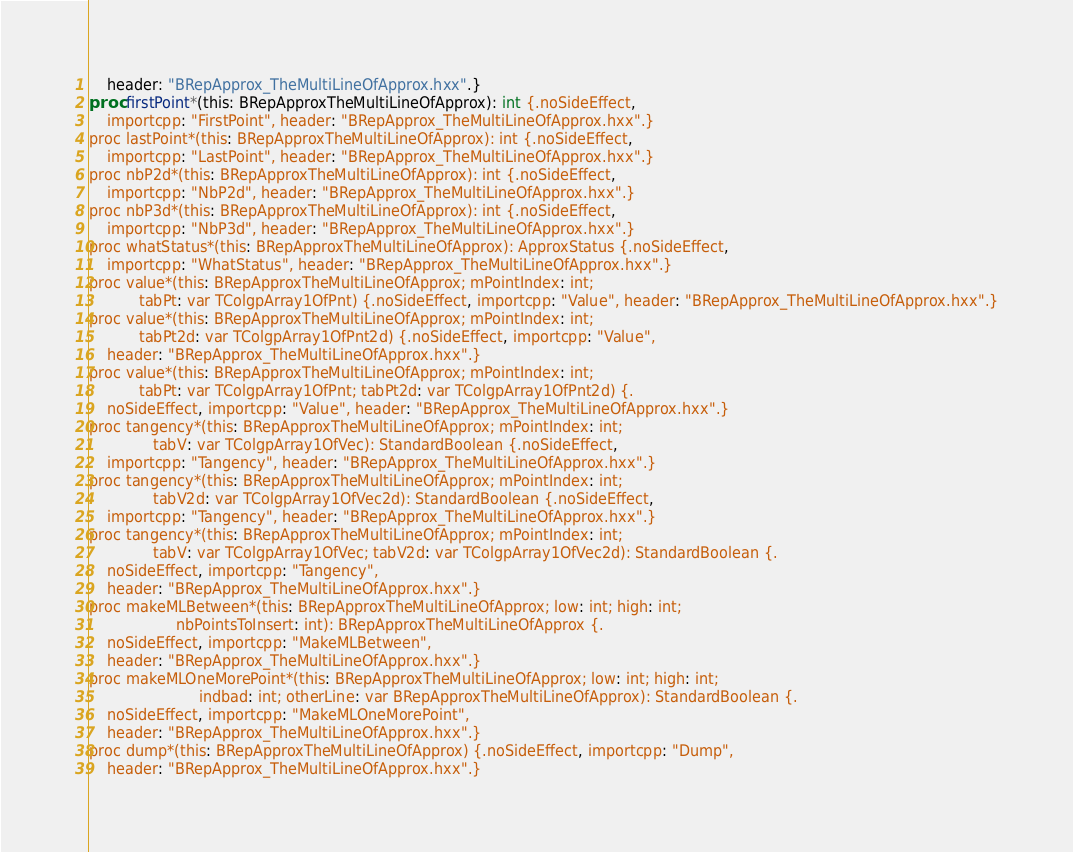<code> <loc_0><loc_0><loc_500><loc_500><_Nim_>    header: "BRepApprox_TheMultiLineOfApprox.hxx".}
proc firstPoint*(this: BRepApproxTheMultiLineOfApprox): int {.noSideEffect,
    importcpp: "FirstPoint", header: "BRepApprox_TheMultiLineOfApprox.hxx".}
proc lastPoint*(this: BRepApproxTheMultiLineOfApprox): int {.noSideEffect,
    importcpp: "LastPoint", header: "BRepApprox_TheMultiLineOfApprox.hxx".}
proc nbP2d*(this: BRepApproxTheMultiLineOfApprox): int {.noSideEffect,
    importcpp: "NbP2d", header: "BRepApprox_TheMultiLineOfApprox.hxx".}
proc nbP3d*(this: BRepApproxTheMultiLineOfApprox): int {.noSideEffect,
    importcpp: "NbP3d", header: "BRepApprox_TheMultiLineOfApprox.hxx".}
proc whatStatus*(this: BRepApproxTheMultiLineOfApprox): ApproxStatus {.noSideEffect,
    importcpp: "WhatStatus", header: "BRepApprox_TheMultiLineOfApprox.hxx".}
proc value*(this: BRepApproxTheMultiLineOfApprox; mPointIndex: int;
           tabPt: var TColgpArray1OfPnt) {.noSideEffect, importcpp: "Value", header: "BRepApprox_TheMultiLineOfApprox.hxx".}
proc value*(this: BRepApproxTheMultiLineOfApprox; mPointIndex: int;
           tabPt2d: var TColgpArray1OfPnt2d) {.noSideEffect, importcpp: "Value",
    header: "BRepApprox_TheMultiLineOfApprox.hxx".}
proc value*(this: BRepApproxTheMultiLineOfApprox; mPointIndex: int;
           tabPt: var TColgpArray1OfPnt; tabPt2d: var TColgpArray1OfPnt2d) {.
    noSideEffect, importcpp: "Value", header: "BRepApprox_TheMultiLineOfApprox.hxx".}
proc tangency*(this: BRepApproxTheMultiLineOfApprox; mPointIndex: int;
              tabV: var TColgpArray1OfVec): StandardBoolean {.noSideEffect,
    importcpp: "Tangency", header: "BRepApprox_TheMultiLineOfApprox.hxx".}
proc tangency*(this: BRepApproxTheMultiLineOfApprox; mPointIndex: int;
              tabV2d: var TColgpArray1OfVec2d): StandardBoolean {.noSideEffect,
    importcpp: "Tangency", header: "BRepApprox_TheMultiLineOfApprox.hxx".}
proc tangency*(this: BRepApproxTheMultiLineOfApprox; mPointIndex: int;
              tabV: var TColgpArray1OfVec; tabV2d: var TColgpArray1OfVec2d): StandardBoolean {.
    noSideEffect, importcpp: "Tangency",
    header: "BRepApprox_TheMultiLineOfApprox.hxx".}
proc makeMLBetween*(this: BRepApproxTheMultiLineOfApprox; low: int; high: int;
                   nbPointsToInsert: int): BRepApproxTheMultiLineOfApprox {.
    noSideEffect, importcpp: "MakeMLBetween",
    header: "BRepApprox_TheMultiLineOfApprox.hxx".}
proc makeMLOneMorePoint*(this: BRepApproxTheMultiLineOfApprox; low: int; high: int;
                        indbad: int; otherLine: var BRepApproxTheMultiLineOfApprox): StandardBoolean {.
    noSideEffect, importcpp: "MakeMLOneMorePoint",
    header: "BRepApprox_TheMultiLineOfApprox.hxx".}
proc dump*(this: BRepApproxTheMultiLineOfApprox) {.noSideEffect, importcpp: "Dump",
    header: "BRepApprox_TheMultiLineOfApprox.hxx".}</code> 